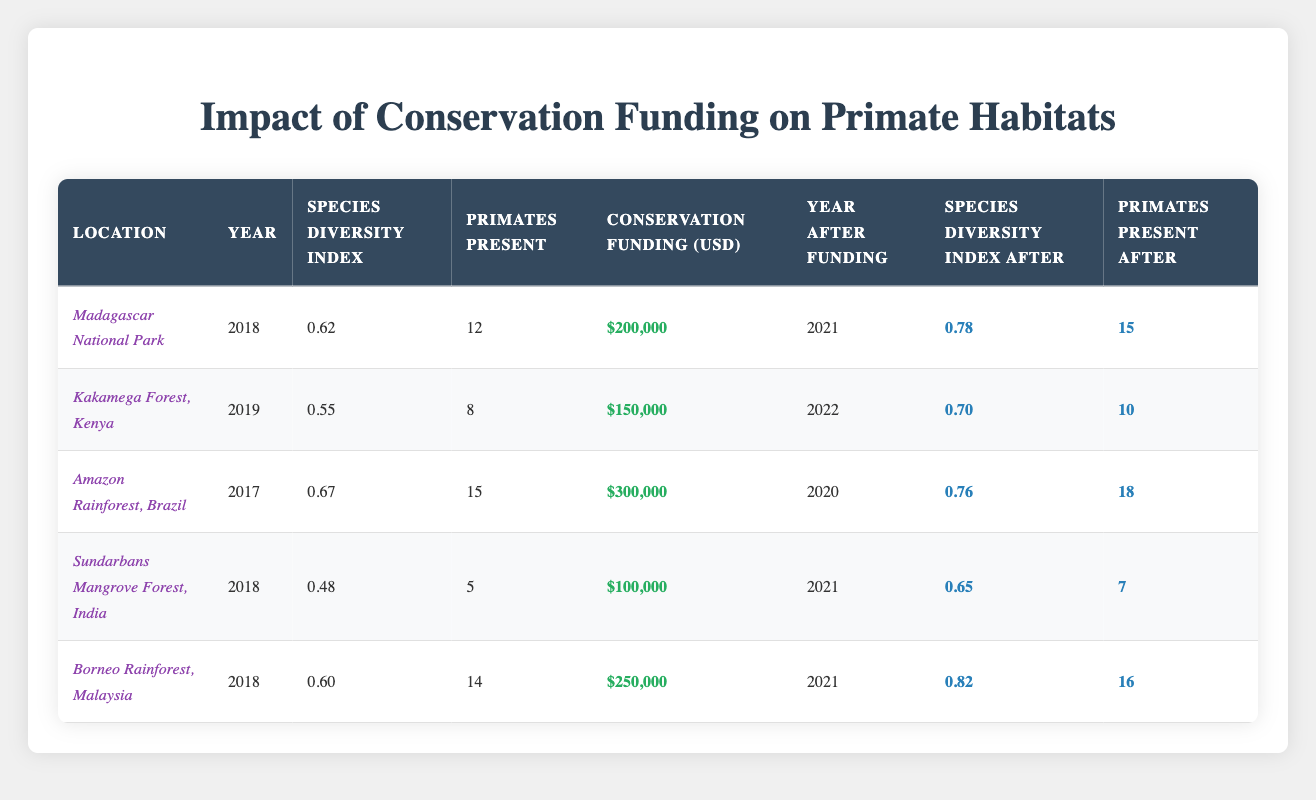What is the species diversity index in Madagascar National Park before conservation funding? In the table, the species diversity index for Madagascar National Park is listed as 0.62 in the year 2018, which is before the implementation of conservation funding.
Answer: 0.62 How many primates were present in the Amazon Rainforest before funding was allocated? Referring to the table, the number of primates present in the Amazon Rainforest in 2017, before funding was allocated, is recorded as 15.
Answer: 15 Which location received the highest amount of conservation funding? In the table, the Amazon Rainforest received the highest funding amount, listed at $300,000.
Answer: $300,000 What is the average species diversity index after conservation funding in all listed locations? The species diversity indices after funding are 0.78, 0.70, 0.76, 0.65, and 0.82. Adding these values gives 0.78 + 0.70 + 0.76 + 0.65 + 0.82 = 3.71. To find the average, divide the sum by the number of locations: 3.71 / 5 = 0.742.
Answer: 0.742 Did the number of primates present in the Sundarbans Mangrove Forest increase after funding? By comparing the number of primates present before and after funding, we see that it increased from 5 to 7. Therefore, there was an increase in the number of primates.
Answer: Yes What is the difference in species diversity index before and after funding for Kakamega Forest? The species diversity index for Kakamega Forest before funding was 0.55, and after funding, it was 0.70. The difference is calculated by subtracting the before value from the after value: 0.70 - 0.55 = 0.15.
Answer: 0.15 How many total primates were present in all locations after funding was implemented? The numbers of primates present after funding are 15 (Madagascar) + 10 (Kakamega) + 18 (Amazon) + 7 (Sundarbans) + 16 (Borneo) = 66.
Answer: 66 Is the species diversity index always higher after funding than before funding across all locations? By examining the table, we see that in all cases, the species diversity index after funding (0.78, 0.70, 0.76, 0.65, 0.82) is higher than before funding (0.62, 0.55, 0.67, 0.48, 0.60). Therefore, the statement is true.
Answer: Yes Which location had the least increase in the species diversity index as a result of funding? The differences in species diversity index increases for the locations are: Madagascar (0.16), Kakamega (0.15), Amazon (0.09), Sundarbans (0.17), and Borneo (0.22). Kakamega had the least increase with 0.15.
Answer: Kakamega Forest, Kenya 